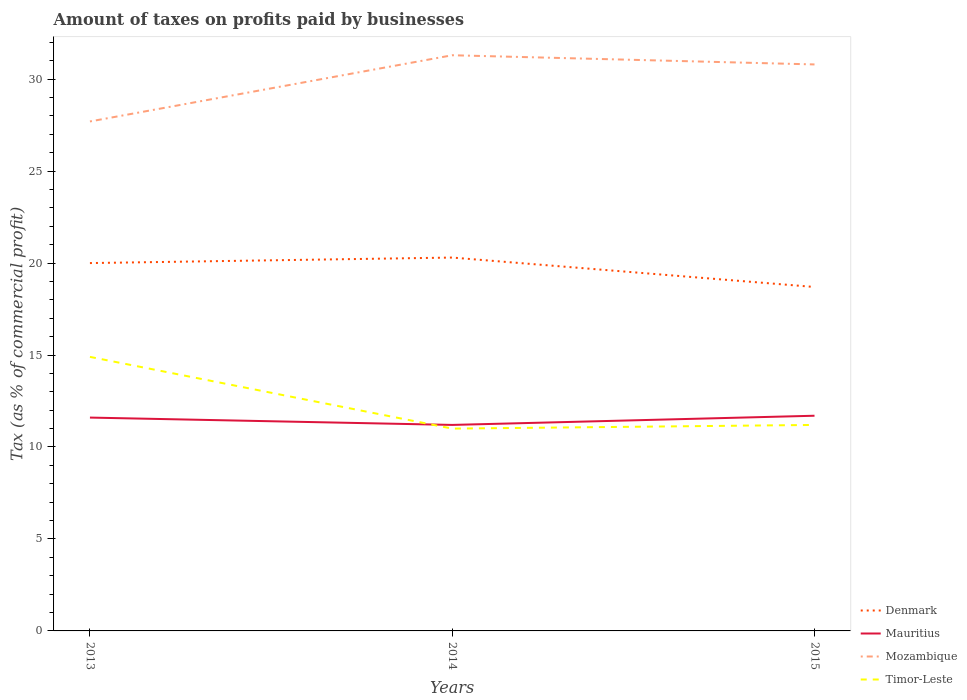Across all years, what is the maximum percentage of taxes paid by businesses in Denmark?
Provide a short and direct response. 18.7. In which year was the percentage of taxes paid by businesses in Denmark maximum?
Provide a succinct answer. 2015. What is the total percentage of taxes paid by businesses in Denmark in the graph?
Your answer should be very brief. 1.3. What is the difference between the highest and the second highest percentage of taxes paid by businesses in Mozambique?
Your response must be concise. 3.6. What is the difference between the highest and the lowest percentage of taxes paid by businesses in Mauritius?
Provide a short and direct response. 2. How many lines are there?
Make the answer very short. 4. How many years are there in the graph?
Ensure brevity in your answer.  3. What is the difference between two consecutive major ticks on the Y-axis?
Ensure brevity in your answer.  5. Are the values on the major ticks of Y-axis written in scientific E-notation?
Offer a terse response. No. Does the graph contain grids?
Ensure brevity in your answer.  No. Where does the legend appear in the graph?
Keep it short and to the point. Bottom right. How many legend labels are there?
Keep it short and to the point. 4. How are the legend labels stacked?
Your answer should be very brief. Vertical. What is the title of the graph?
Provide a succinct answer. Amount of taxes on profits paid by businesses. Does "Puerto Rico" appear as one of the legend labels in the graph?
Your response must be concise. No. What is the label or title of the X-axis?
Provide a succinct answer. Years. What is the label or title of the Y-axis?
Your response must be concise. Tax (as % of commercial profit). What is the Tax (as % of commercial profit) of Denmark in 2013?
Make the answer very short. 20. What is the Tax (as % of commercial profit) of Mozambique in 2013?
Provide a short and direct response. 27.7. What is the Tax (as % of commercial profit) of Timor-Leste in 2013?
Make the answer very short. 14.9. What is the Tax (as % of commercial profit) in Denmark in 2014?
Ensure brevity in your answer.  20.3. What is the Tax (as % of commercial profit) in Mauritius in 2014?
Ensure brevity in your answer.  11.2. What is the Tax (as % of commercial profit) of Mozambique in 2014?
Provide a short and direct response. 31.3. What is the Tax (as % of commercial profit) in Denmark in 2015?
Keep it short and to the point. 18.7. What is the Tax (as % of commercial profit) of Mauritius in 2015?
Your answer should be compact. 11.7. What is the Tax (as % of commercial profit) in Mozambique in 2015?
Ensure brevity in your answer.  30.8. Across all years, what is the maximum Tax (as % of commercial profit) of Denmark?
Make the answer very short. 20.3. Across all years, what is the maximum Tax (as % of commercial profit) of Mauritius?
Make the answer very short. 11.7. Across all years, what is the maximum Tax (as % of commercial profit) in Mozambique?
Make the answer very short. 31.3. Across all years, what is the maximum Tax (as % of commercial profit) of Timor-Leste?
Keep it short and to the point. 14.9. Across all years, what is the minimum Tax (as % of commercial profit) in Mauritius?
Keep it short and to the point. 11.2. Across all years, what is the minimum Tax (as % of commercial profit) of Mozambique?
Provide a short and direct response. 27.7. Across all years, what is the minimum Tax (as % of commercial profit) of Timor-Leste?
Your response must be concise. 11. What is the total Tax (as % of commercial profit) in Mauritius in the graph?
Offer a terse response. 34.5. What is the total Tax (as % of commercial profit) of Mozambique in the graph?
Provide a short and direct response. 89.8. What is the total Tax (as % of commercial profit) in Timor-Leste in the graph?
Provide a short and direct response. 37.1. What is the difference between the Tax (as % of commercial profit) in Denmark in 2013 and that in 2014?
Your answer should be compact. -0.3. What is the difference between the Tax (as % of commercial profit) in Mozambique in 2013 and that in 2014?
Offer a very short reply. -3.6. What is the difference between the Tax (as % of commercial profit) in Mauritius in 2014 and that in 2015?
Ensure brevity in your answer.  -0.5. What is the difference between the Tax (as % of commercial profit) in Denmark in 2013 and the Tax (as % of commercial profit) in Mozambique in 2014?
Provide a succinct answer. -11.3. What is the difference between the Tax (as % of commercial profit) of Denmark in 2013 and the Tax (as % of commercial profit) of Timor-Leste in 2014?
Provide a short and direct response. 9. What is the difference between the Tax (as % of commercial profit) of Mauritius in 2013 and the Tax (as % of commercial profit) of Mozambique in 2014?
Your response must be concise. -19.7. What is the difference between the Tax (as % of commercial profit) in Mozambique in 2013 and the Tax (as % of commercial profit) in Timor-Leste in 2014?
Provide a succinct answer. 16.7. What is the difference between the Tax (as % of commercial profit) of Denmark in 2013 and the Tax (as % of commercial profit) of Timor-Leste in 2015?
Give a very brief answer. 8.8. What is the difference between the Tax (as % of commercial profit) of Mauritius in 2013 and the Tax (as % of commercial profit) of Mozambique in 2015?
Provide a short and direct response. -19.2. What is the difference between the Tax (as % of commercial profit) in Mozambique in 2013 and the Tax (as % of commercial profit) in Timor-Leste in 2015?
Offer a terse response. 16.5. What is the difference between the Tax (as % of commercial profit) of Mauritius in 2014 and the Tax (as % of commercial profit) of Mozambique in 2015?
Offer a very short reply. -19.6. What is the difference between the Tax (as % of commercial profit) of Mauritius in 2014 and the Tax (as % of commercial profit) of Timor-Leste in 2015?
Provide a succinct answer. 0. What is the difference between the Tax (as % of commercial profit) of Mozambique in 2014 and the Tax (as % of commercial profit) of Timor-Leste in 2015?
Your response must be concise. 20.1. What is the average Tax (as % of commercial profit) in Denmark per year?
Ensure brevity in your answer.  19.67. What is the average Tax (as % of commercial profit) in Mauritius per year?
Your answer should be very brief. 11.5. What is the average Tax (as % of commercial profit) in Mozambique per year?
Give a very brief answer. 29.93. What is the average Tax (as % of commercial profit) in Timor-Leste per year?
Your response must be concise. 12.37. In the year 2013, what is the difference between the Tax (as % of commercial profit) of Denmark and Tax (as % of commercial profit) of Mauritius?
Your answer should be very brief. 8.4. In the year 2013, what is the difference between the Tax (as % of commercial profit) in Mauritius and Tax (as % of commercial profit) in Mozambique?
Provide a succinct answer. -16.1. In the year 2013, what is the difference between the Tax (as % of commercial profit) of Mauritius and Tax (as % of commercial profit) of Timor-Leste?
Provide a succinct answer. -3.3. In the year 2014, what is the difference between the Tax (as % of commercial profit) in Denmark and Tax (as % of commercial profit) in Mozambique?
Give a very brief answer. -11. In the year 2014, what is the difference between the Tax (as % of commercial profit) of Mauritius and Tax (as % of commercial profit) of Mozambique?
Make the answer very short. -20.1. In the year 2014, what is the difference between the Tax (as % of commercial profit) of Mozambique and Tax (as % of commercial profit) of Timor-Leste?
Your response must be concise. 20.3. In the year 2015, what is the difference between the Tax (as % of commercial profit) in Denmark and Tax (as % of commercial profit) in Mauritius?
Ensure brevity in your answer.  7. In the year 2015, what is the difference between the Tax (as % of commercial profit) in Denmark and Tax (as % of commercial profit) in Mozambique?
Give a very brief answer. -12.1. In the year 2015, what is the difference between the Tax (as % of commercial profit) of Denmark and Tax (as % of commercial profit) of Timor-Leste?
Provide a short and direct response. 7.5. In the year 2015, what is the difference between the Tax (as % of commercial profit) in Mauritius and Tax (as % of commercial profit) in Mozambique?
Your answer should be compact. -19.1. In the year 2015, what is the difference between the Tax (as % of commercial profit) of Mozambique and Tax (as % of commercial profit) of Timor-Leste?
Ensure brevity in your answer.  19.6. What is the ratio of the Tax (as % of commercial profit) in Denmark in 2013 to that in 2014?
Offer a very short reply. 0.99. What is the ratio of the Tax (as % of commercial profit) of Mauritius in 2013 to that in 2014?
Your answer should be compact. 1.04. What is the ratio of the Tax (as % of commercial profit) in Mozambique in 2013 to that in 2014?
Offer a very short reply. 0.89. What is the ratio of the Tax (as % of commercial profit) in Timor-Leste in 2013 to that in 2014?
Offer a very short reply. 1.35. What is the ratio of the Tax (as % of commercial profit) of Denmark in 2013 to that in 2015?
Make the answer very short. 1.07. What is the ratio of the Tax (as % of commercial profit) of Mozambique in 2013 to that in 2015?
Provide a succinct answer. 0.9. What is the ratio of the Tax (as % of commercial profit) of Timor-Leste in 2013 to that in 2015?
Your answer should be very brief. 1.33. What is the ratio of the Tax (as % of commercial profit) in Denmark in 2014 to that in 2015?
Provide a succinct answer. 1.09. What is the ratio of the Tax (as % of commercial profit) of Mauritius in 2014 to that in 2015?
Offer a terse response. 0.96. What is the ratio of the Tax (as % of commercial profit) of Mozambique in 2014 to that in 2015?
Provide a short and direct response. 1.02. What is the ratio of the Tax (as % of commercial profit) of Timor-Leste in 2014 to that in 2015?
Your answer should be compact. 0.98. What is the difference between the highest and the second highest Tax (as % of commercial profit) of Mauritius?
Provide a succinct answer. 0.1. What is the difference between the highest and the second highest Tax (as % of commercial profit) of Mozambique?
Your answer should be compact. 0.5. What is the difference between the highest and the second highest Tax (as % of commercial profit) in Timor-Leste?
Keep it short and to the point. 3.7. What is the difference between the highest and the lowest Tax (as % of commercial profit) in Denmark?
Provide a succinct answer. 1.6. What is the difference between the highest and the lowest Tax (as % of commercial profit) in Mauritius?
Keep it short and to the point. 0.5. 